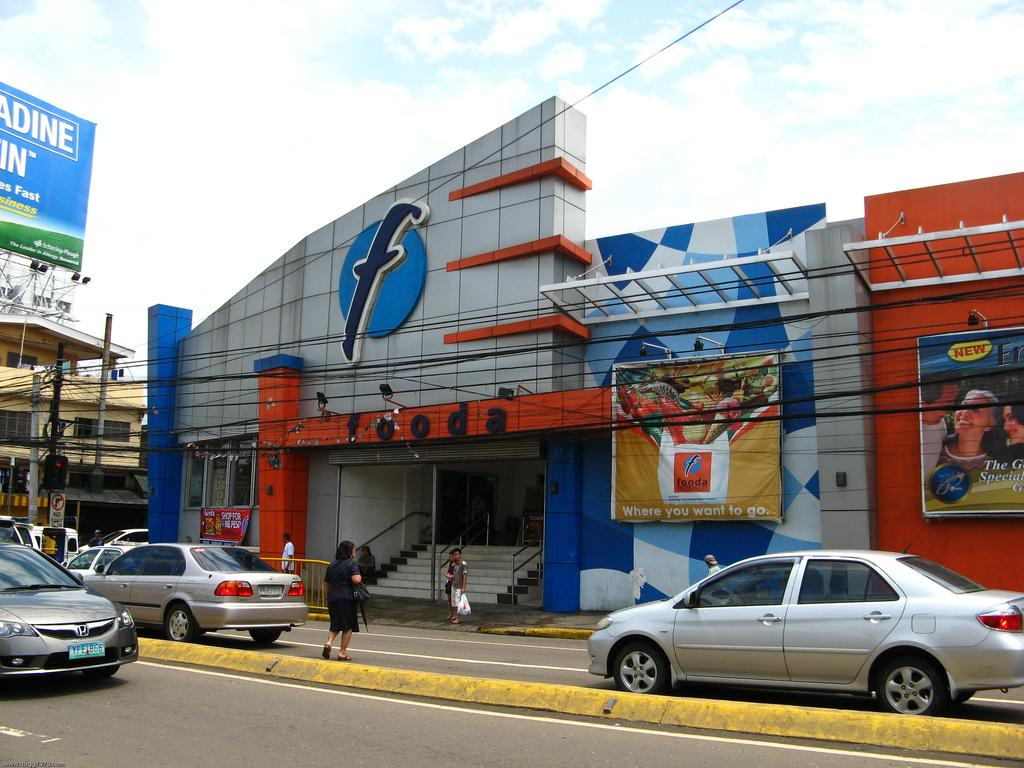<image>
Summarize the visual content of the image. A street view of a Fooda supermarket building facade 